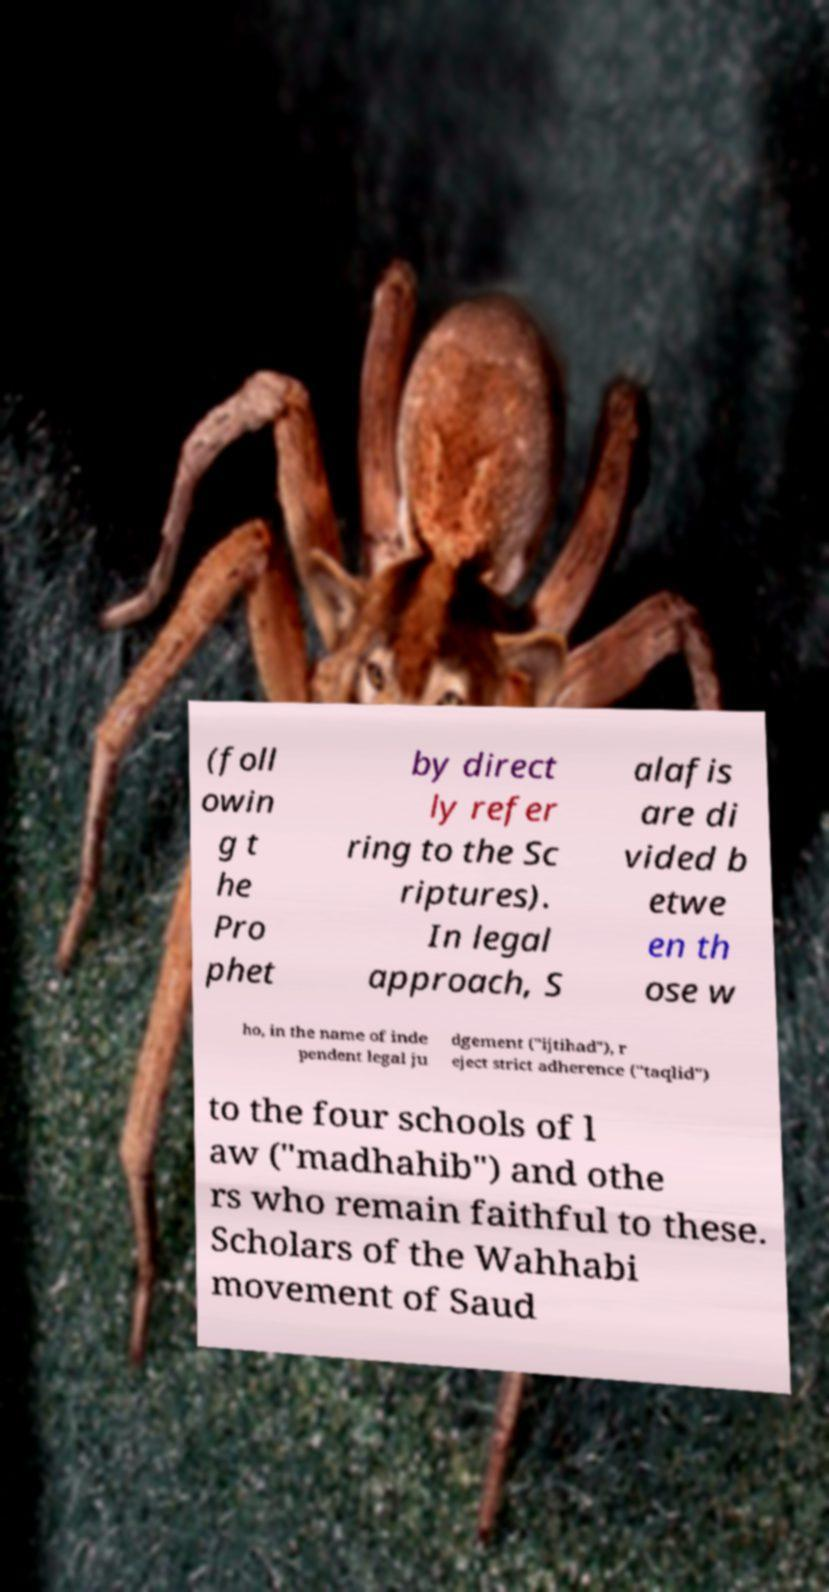Can you read and provide the text displayed in the image?This photo seems to have some interesting text. Can you extract and type it out for me? (foll owin g t he Pro phet by direct ly refer ring to the Sc riptures). In legal approach, S alafis are di vided b etwe en th ose w ho, in the name of inde pendent legal ju dgement ("ijtihad"), r eject strict adherence ("taqlid") to the four schools of l aw ("madhahib") and othe rs who remain faithful to these. Scholars of the Wahhabi movement of Saud 